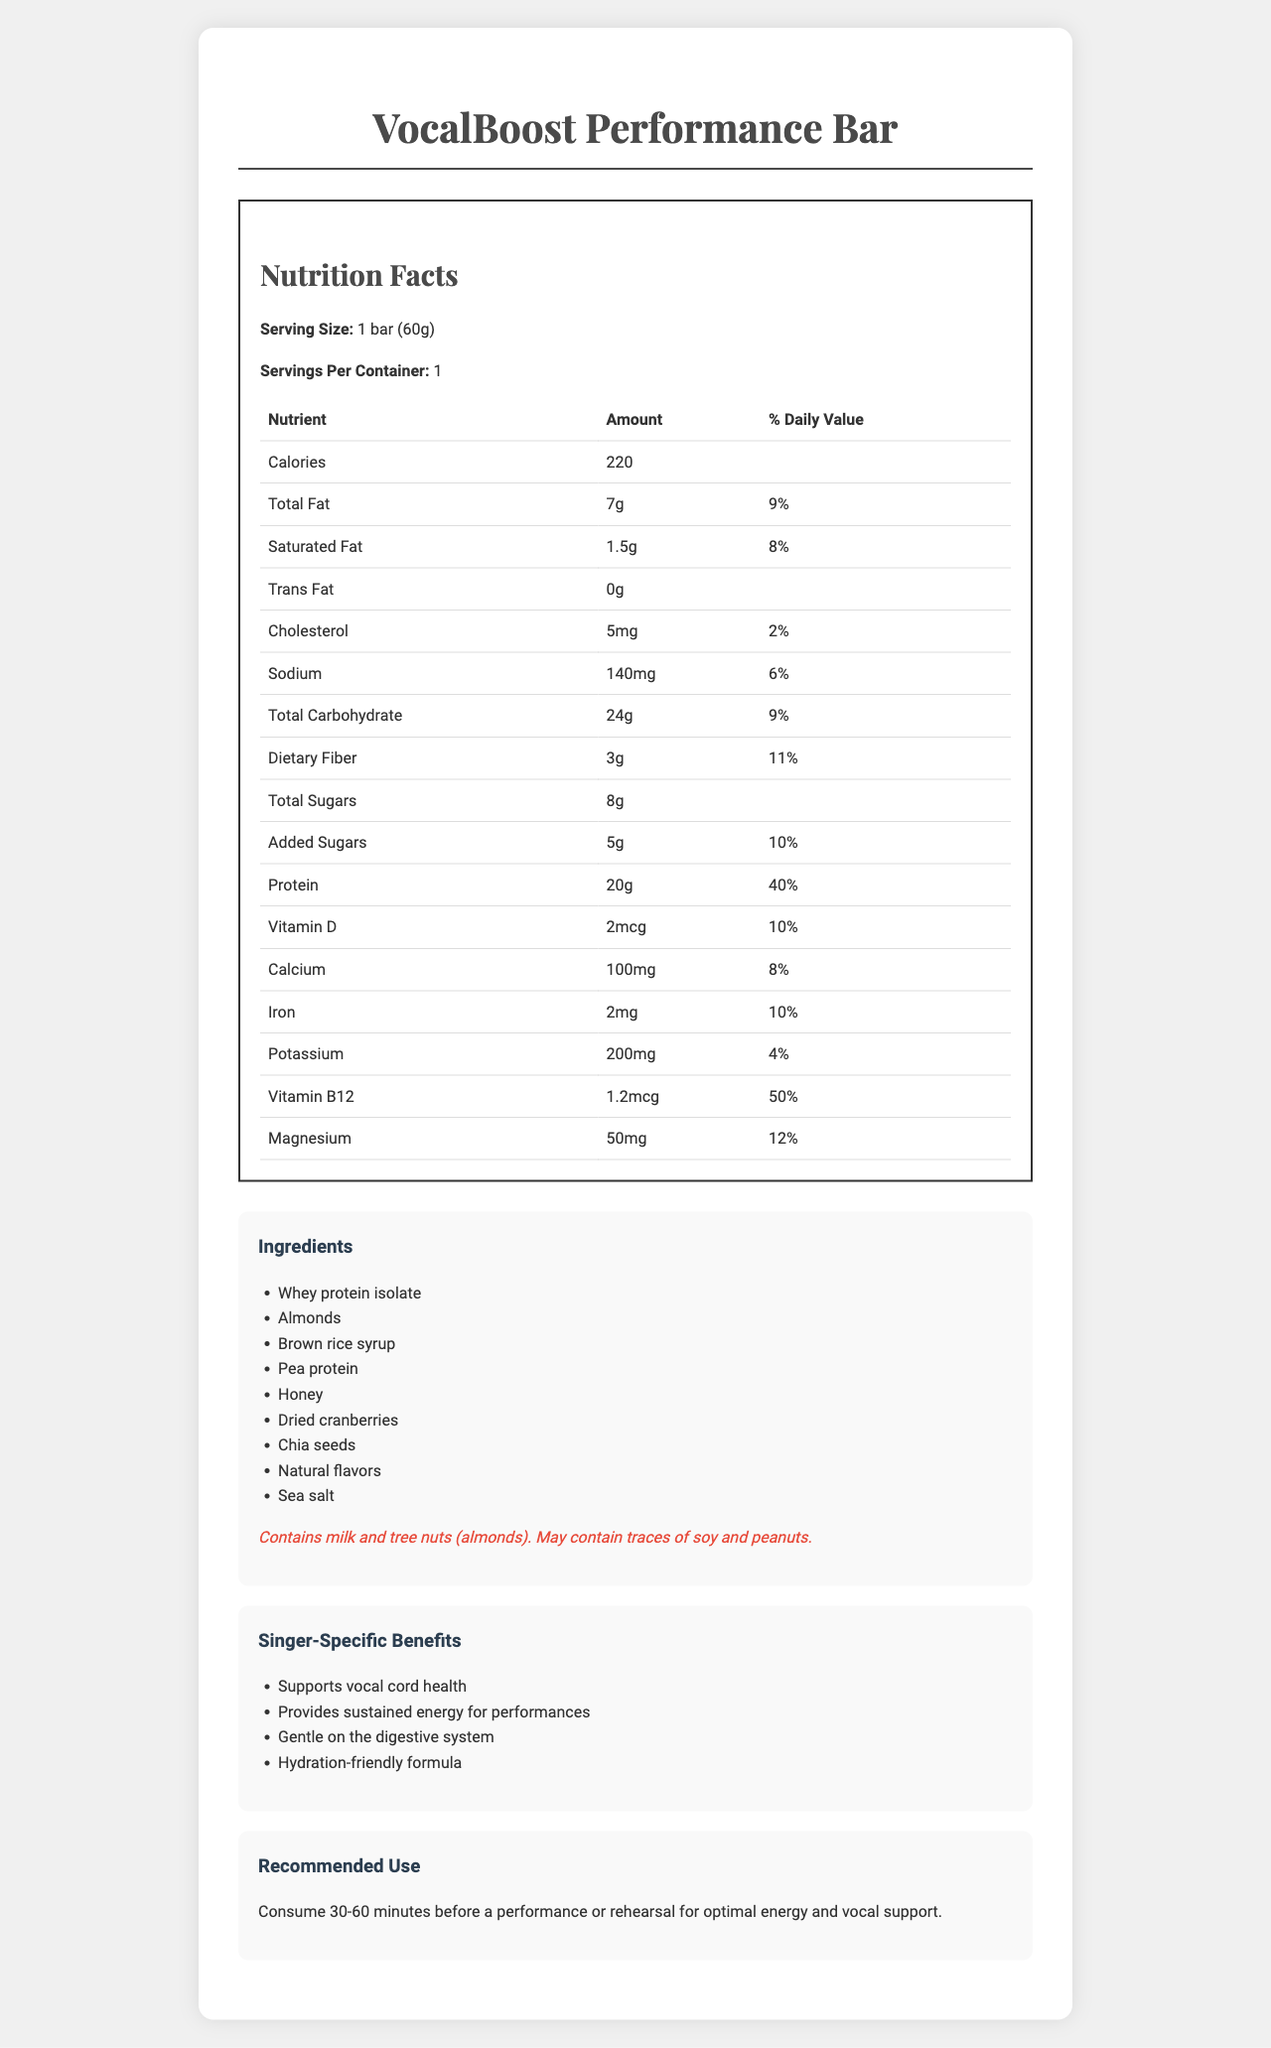what is the serving size? The serving size is mentioned explicitly at the top of the nutrition facts section as "Serving Size: 1 bar (60g)".
Answer: 1 bar (60g) how many calories are in one serving of the VocalBoost Performance Bar? The nutrition facts table lists the calories amount directly as 220.
Answer: 220 what is the percentage of daily value for protein? The nutrition facts table states the protein amount as "20g," and the % daily value is given as "40%".
Answer: 40% what are the first three ingredients listed for the VocalBoost Performance Bar? The ingredients list is provided in a sequential order, with the first three being Whey protein isolate, Almonds, and Brown rice syrup.
Answer: Whey protein isolate, Almonds, Brown rice syrup how much total fat is in the VocalBoost Performance Bar? The total fat amount is listed in the nutrition facts table as "Total Fat: 7g".
Answer: 7g what is the daily value percentage of Dietary Fiber? The daily value percentage of Dietary Fiber is presented in the nutrition facts table as "11%".
Answer: 11% how much Vitamin B12 does the bar contain? The Vitamin B12 content is noted in the nutrition facts table as "1.2mcg".
Answer: 1.2mcg does the VocalBoost Performance Bar contain any trans fat? The nutrition facts indicate that the Trans Fat amount is "0g".
Answer: No what should be the recommended use of this bar for singers? The recommended use section advises consuming the bar 30-60 minutes before a performance or rehearsal for optimal energy and vocal support.
Answer: Consume 30-60 minutes before a performance or rehearsal for optimal energy and vocal support. what allergens does the VocalBoost Performance Bar contain? The allergen information clearly states that the bar contains milk and tree nuts (almonds).
Answer: Milk and tree nuts (almonds) which ingredient is not in the VocalBoost Performance Bar? A. Chia seeds B. Brown rice syrup C. Peanuts D. Dried cranberries The ingredients list includes Chia seeds, Brown rice syrup, and Dried cranberries, but Peanuts are only mentioned as a potential trace allergen, not as a primary ingredient.
Answer: C. Peanuts how much sugar is added to the VocalBoost Performance Bar? A. 3g B. 5g C. 8g D. 10g The document specifies that the bar has “Added Sugars: 5g”.
Answer: B. 5g what is the daily value percentage for saturated fat? The nutrition facts table indicates the daily value percentage for saturated fat as "8%".
Answer: 8% does the VocalBoost Performance Bar assist in hydrating singers? One of the listed singer-specific benefits includes "Hydration-friendly formula".
Answer: Yes summarize the main idea of the document in one sentence. The document primarily focuses on offering comprehensive insight into the nutritional content, beneficial properties for singers, and usage recommendations for the VocalBoost Performance Bar.
Answer: The document provides detailed nutritional information, ingredient lists, allergen warnings, and specific benefits for singers for the VocalBoost Performance Bar, along with recommended use guidelines. what is the price of one VocalBoost Performance Bar? The document does not provide any information regarding the price of the VocalBoost Performance Bar.
Answer: Cannot be determined 